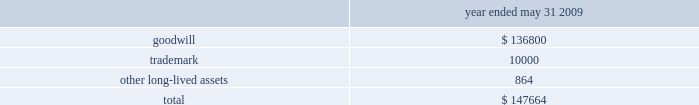The following details the impairment charge resulting from our review ( in thousands ) : .
Net income attributable to noncontrolling interests , net of tax noncontrolling interest , net of tax increased $ 28.9 million from $ 8.1 million fiscal 2008 .
The increase was primarily related to our acquisition of a 51% ( 51 % ) majority interest in hsbc merchant services , llp on june 30 , net income attributable to global payments and diluted earnings per share during fiscal 2009 we reported net income of $ 37.2 million ( $ 0.46 diluted earnings per share ) .
Liquidity and capital resources a significant portion of our liquidity comes from operating cash flows , which are generally sufficient to fund operations , planned capital expenditures , debt service and various strategic investments in our business .
Cash flow from operations is used to make planned capital investments in our business , to pursue acquisitions that meet our corporate objectives , to pay dividends , and to pay off debt and repurchase our shares at the discretion of our board of directors .
Accumulated cash balances are invested in high-quality and marketable short term instruments .
Our capital plan objectives are to support the company 2019s operational needs and strategic plan for long term growth while maintaining a low cost of capital .
Lines of credit are used in certain of our markets to fund settlement and as a source of working capital and , along with other bank financing , to fund acquisitions .
We regularly evaluate our liquidity and capital position relative to cash requirements , and we may elect to raise additional funds in the future , either through the issuance of debt , equity or otherwise .
At may 31 , 2010 , we had cash and cash equivalents totaling $ 769.9 million .
Of this amount , we consider $ 268.1 million to be available cash , which generally excludes settlement related and merchant reserve cash balances .
Settlement related cash balances represent surplus funds that we hold on behalf of our member sponsors when the incoming amount from the card networks precedes the member sponsors 2019 funding obligation to the merchant .
Merchant reserve cash balances represent funds collected from our merchants that serve as collateral ( 201cmerchant reserves 201d ) to minimize contingent liabilities associated with any losses that may occur under the merchant agreement .
At may 31 , 2010 , our cash and cash equivalents included $ 199.4 million related to merchant reserves .
While this cash is not restricted in its use , we believe that designating this cash to collateralize merchant reserves strengthens our fiduciary standing with our member sponsors and is in accordance with the guidelines set by the card networks .
See cash and cash equivalents and settlement processing assets and obligations under note 1 in the notes to the consolidated financial statements for additional details .
Net cash provided by operating activities increased $ 82.8 million to $ 465.8 million for fiscal 2010 from the prior year .
Income from continuing operations increased $ 16.0 million and we had cash provided by changes in working capital of $ 60.2 million .
The working capital change was primarily due to the change in net settlement processing assets and obligations of $ 80.3 million and the change in accounts receivable of $ 13.4 million , partially offset by the change .
What portion of the impairment charge is related to goodwill? 
Computations: (136800 / 147664)
Answer: 0.92643. The following details the impairment charge resulting from our review ( in thousands ) : .
Net income attributable to noncontrolling interests , net of tax noncontrolling interest , net of tax increased $ 28.9 million from $ 8.1 million fiscal 2008 .
The increase was primarily related to our acquisition of a 51% ( 51 % ) majority interest in hsbc merchant services , llp on june 30 , net income attributable to global payments and diluted earnings per share during fiscal 2009 we reported net income of $ 37.2 million ( $ 0.46 diluted earnings per share ) .
Liquidity and capital resources a significant portion of our liquidity comes from operating cash flows , which are generally sufficient to fund operations , planned capital expenditures , debt service and various strategic investments in our business .
Cash flow from operations is used to make planned capital investments in our business , to pursue acquisitions that meet our corporate objectives , to pay dividends , and to pay off debt and repurchase our shares at the discretion of our board of directors .
Accumulated cash balances are invested in high-quality and marketable short term instruments .
Our capital plan objectives are to support the company 2019s operational needs and strategic plan for long term growth while maintaining a low cost of capital .
Lines of credit are used in certain of our markets to fund settlement and as a source of working capital and , along with other bank financing , to fund acquisitions .
We regularly evaluate our liquidity and capital position relative to cash requirements , and we may elect to raise additional funds in the future , either through the issuance of debt , equity or otherwise .
At may 31 , 2010 , we had cash and cash equivalents totaling $ 769.9 million .
Of this amount , we consider $ 268.1 million to be available cash , which generally excludes settlement related and merchant reserve cash balances .
Settlement related cash balances represent surplus funds that we hold on behalf of our member sponsors when the incoming amount from the card networks precedes the member sponsors 2019 funding obligation to the merchant .
Merchant reserve cash balances represent funds collected from our merchants that serve as collateral ( 201cmerchant reserves 201d ) to minimize contingent liabilities associated with any losses that may occur under the merchant agreement .
At may 31 , 2010 , our cash and cash equivalents included $ 199.4 million related to merchant reserves .
While this cash is not restricted in its use , we believe that designating this cash to collateralize merchant reserves strengthens our fiduciary standing with our member sponsors and is in accordance with the guidelines set by the card networks .
See cash and cash equivalents and settlement processing assets and obligations under note 1 in the notes to the consolidated financial statements for additional details .
Net cash provided by operating activities increased $ 82.8 million to $ 465.8 million for fiscal 2010 from the prior year .
Income from continuing operations increased $ 16.0 million and we had cash provided by changes in working capital of $ 60.2 million .
The working capital change was primarily due to the change in net settlement processing assets and obligations of $ 80.3 million and the change in accounts receivable of $ 13.4 million , partially offset by the change .
What was the percentage that net income attributable to noncontrolling interests , net of tax noncontrolling interest , net of tax increased from 2008 to 2009? 
Rationale: to find the answer one must subtract the totals of the two years and then take that answer and divide it by the total for 2008 .
Computations: ((28.9 - 8.1) / 8.1)
Answer: 2.5679. 